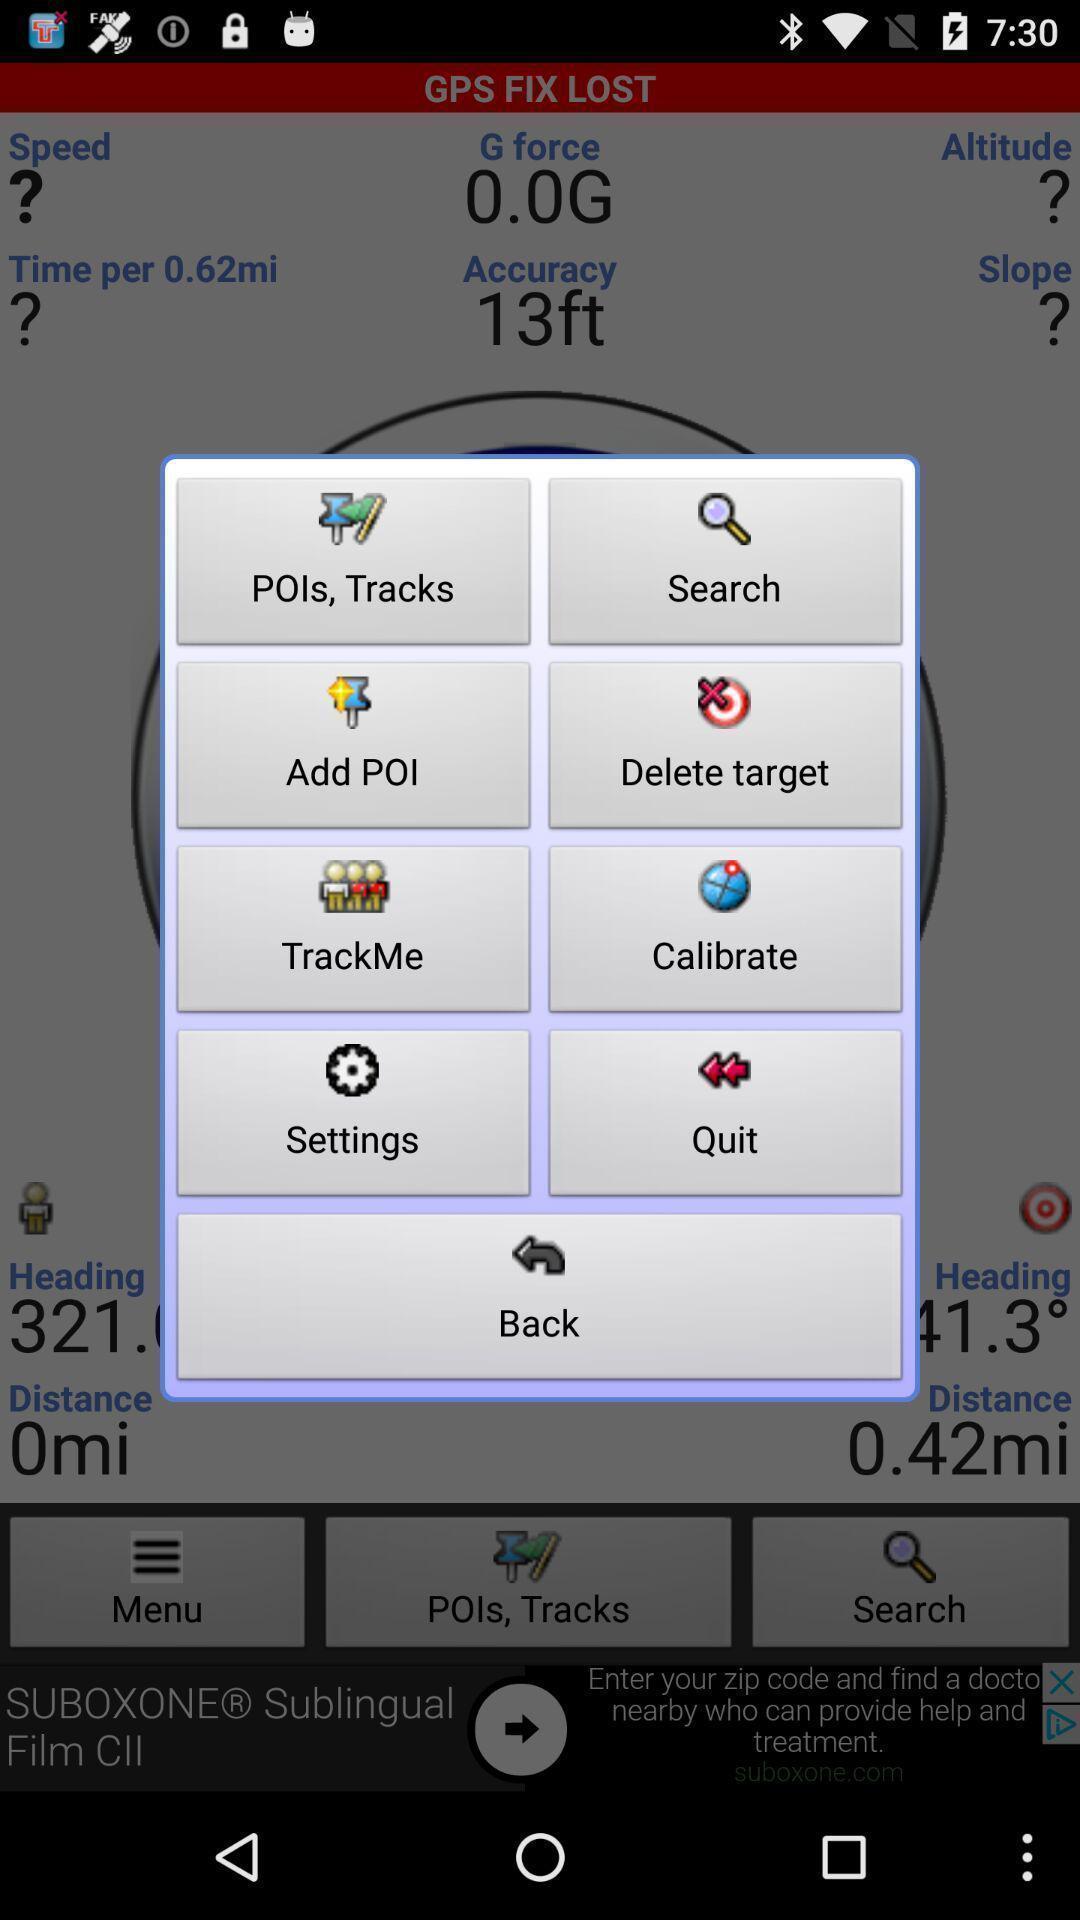Describe this image in words. Popup showing few options with icons. 